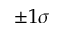<formula> <loc_0><loc_0><loc_500><loc_500>\pm 1 \sigma</formula> 